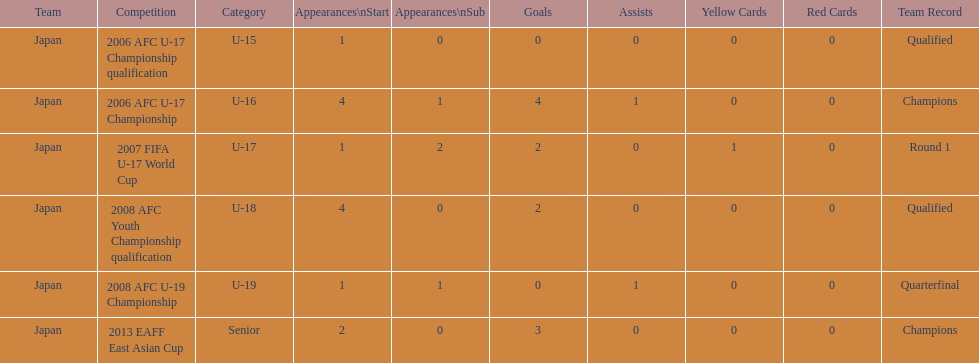Could you help me parse every detail presented in this table? {'header': ['Team', 'Competition', 'Category', 'Appearances\\nStart', 'Appearances\\nSub', 'Goals', 'Assists', 'Yellow Cards', 'Red Cards', 'Team Record'], 'rows': [['Japan', '2006 AFC U-17 Championship qualification', 'U-15', '1', '0', '0', '0', '0', '0', 'Qualified'], ['Japan', '2006 AFC U-17 Championship', 'U-16', '4', '1', '4', '1', '0', '0', 'Champions'], ['Japan', '2007 FIFA U-17 World Cup', 'U-17', '1', '2', '2', '0', '1', '0', 'Round 1'], ['Japan', '2008 AFC Youth Championship qualification', 'U-18', '4', '0', '2', '0', '0', '0', 'Qualified'], ['Japan', '2008 AFC U-19 Championship', 'U-19', '1', '1', '0', '1', '0', '0', 'Quarterfinal'], ['Japan', '2013 EAFF East Asian Cup', 'Senior', '2', '0', '3', '0', '0', '0', 'Champions']]} What competition did japan compete in 2013? 2013 EAFF East Asian Cup. 